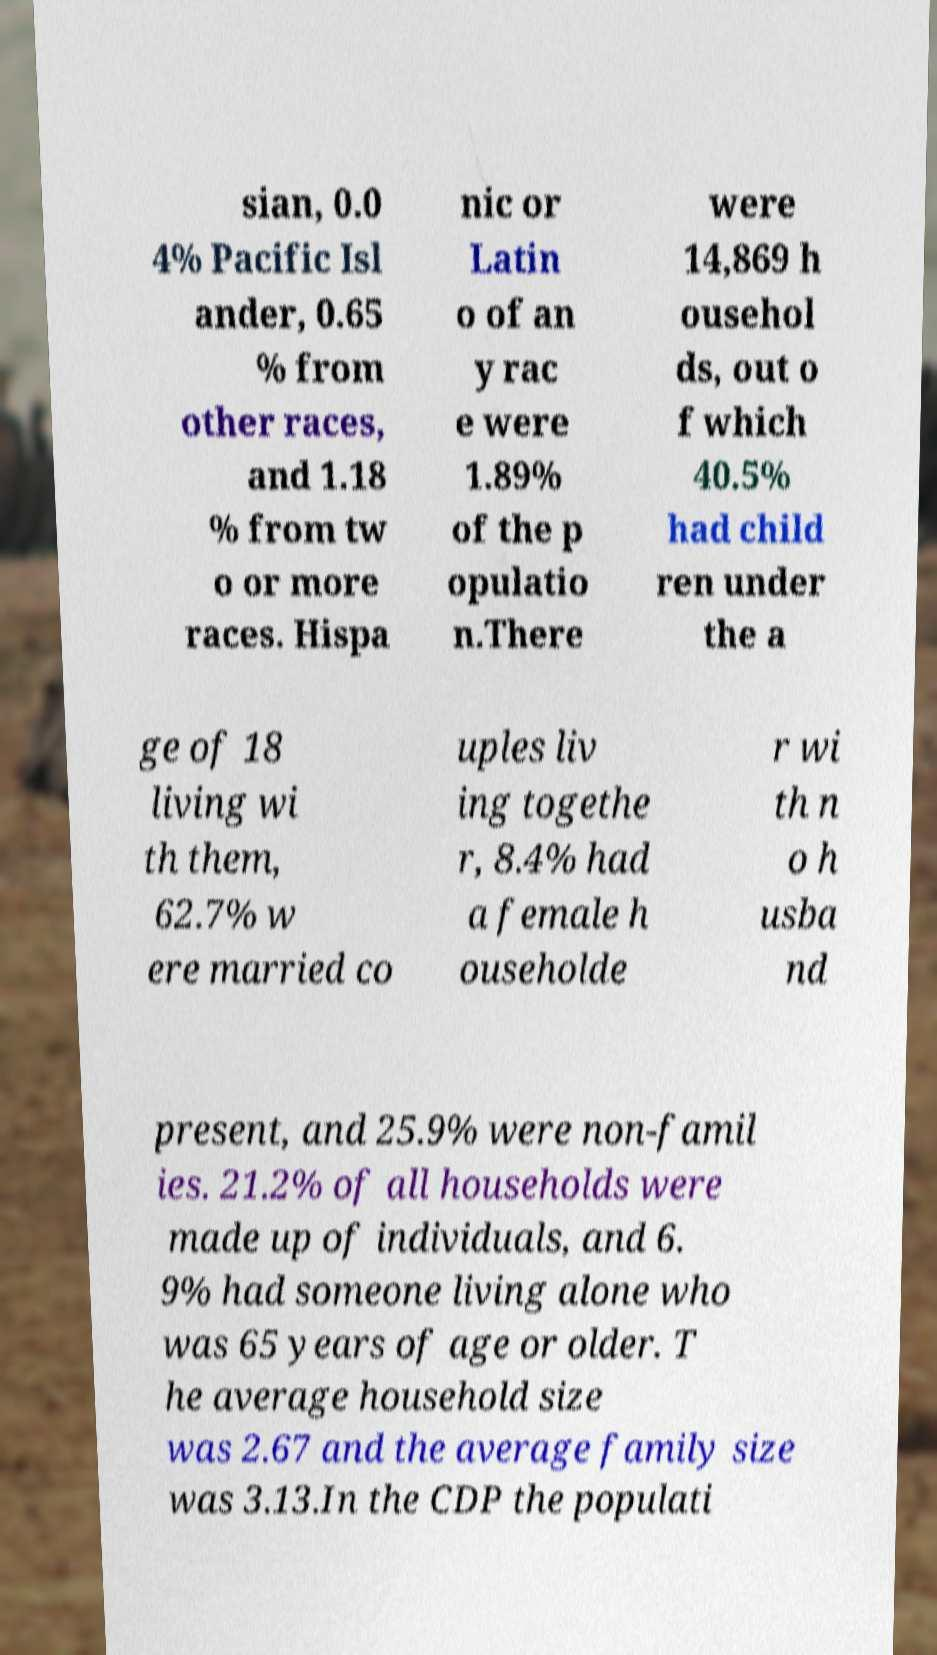What messages or text are displayed in this image? I need them in a readable, typed format. sian, 0.0 4% Pacific Isl ander, 0.65 % from other races, and 1.18 % from tw o or more races. Hispa nic or Latin o of an y rac e were 1.89% of the p opulatio n.There were 14,869 h ousehol ds, out o f which 40.5% had child ren under the a ge of 18 living wi th them, 62.7% w ere married co uples liv ing togethe r, 8.4% had a female h ouseholde r wi th n o h usba nd present, and 25.9% were non-famil ies. 21.2% of all households were made up of individuals, and 6. 9% had someone living alone who was 65 years of age or older. T he average household size was 2.67 and the average family size was 3.13.In the CDP the populati 